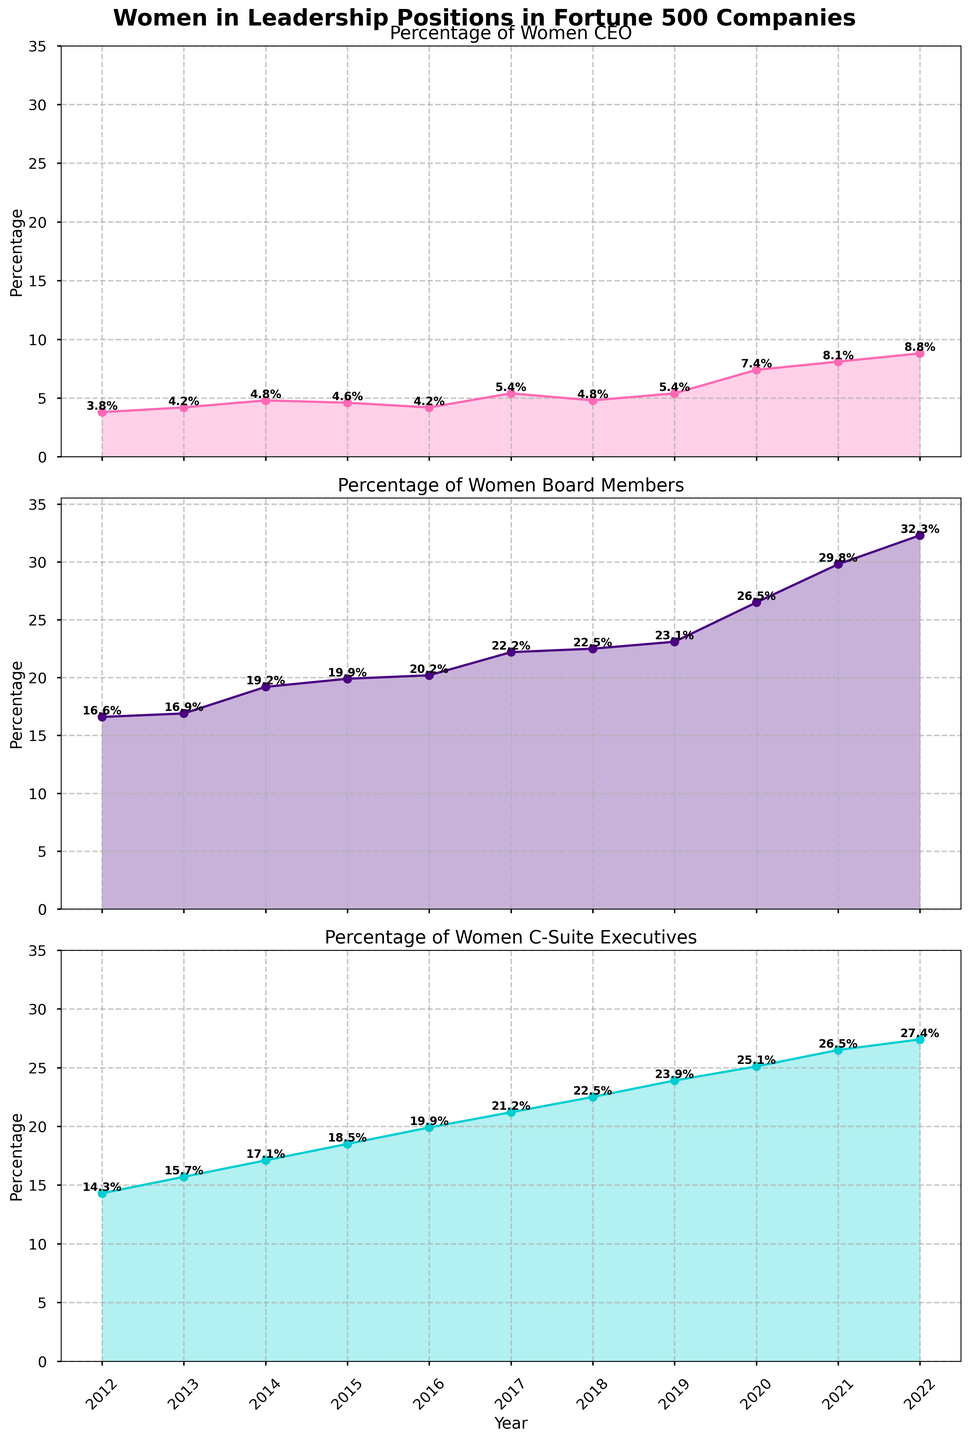What is the title of the first subplot? The title of the first subplot is visible at the top of the first plot in the figure.
Answer: Percentage of Women CEO How did the percentage of women CEO change from 2012 to 2022? The percentage increased from 3.8% in 2012 to 8.8% in 2022.
Answer: Increased Which year saw the highest percentage of women board members? Looking at the second subplot, the highest point is marked in 2022.
Answer: 2022 In which category did women see the smallest percentage increase from 2012 to 2022? By calculating the differences: CEO (8.8 - 3.8 = 5), Board Members (32.3 - 16.6 = 15.7), C-Suite Executives (27.4 - 14.3 = 13.1), the smallest increase is for CEOs.
Answer: CEO What are the axis labels across all the subplots? Each subplot shares the same x-axis labeled "Year"; the y-axis in each snippet is labeled "Percentage".
Answer: Year, Percentage How many years is data plotted for each subplot? Reading the shared x-axis, there are data points from 2012 to 2022, which means 11 years in total.
Answer: 11 In which year did the percentage of women in the C-suite exceed 20% for the first time? In the third subplot, the percentage exceeds 20% in 2016.
Answer: 2016 Which category has shown the most consistent growth over the past decade? Examining the plots, "Board Members" shows a consistent upward trend without major drops or plateaus.
Answer: Board Members Compare the growth trend of women CEOs and board members from 2012 to 2022. While both categories show growth, board members exhibit a more steady increase compared to the slightly fluctuating growth of CEOs.
Answer: Board members more consistent What is the average percentage of women in the C-suite across the entire data set? Summing the percentage values for C-suite and dividing by the number of years: (14.3 + 15.7 + 17.1 + 18.5 + 19.9 + 21.2 + 22.5 + 23.9 + 25.1 + 26.5 + 27.4) / 11 ≈ 21.3.
Answer: 21.3% 